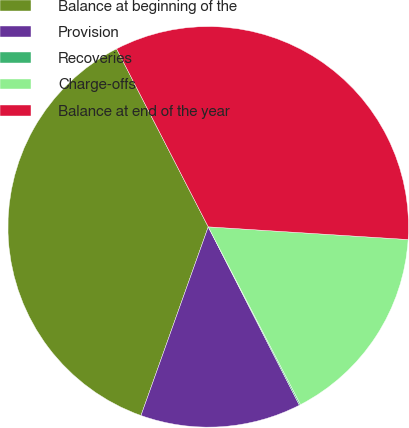<chart> <loc_0><loc_0><loc_500><loc_500><pie_chart><fcel>Balance at beginning of the<fcel>Provision<fcel>Recoveries<fcel>Charge-offs<fcel>Balance at end of the year<nl><fcel>36.98%<fcel>12.97%<fcel>0.1%<fcel>16.37%<fcel>33.58%<nl></chart> 